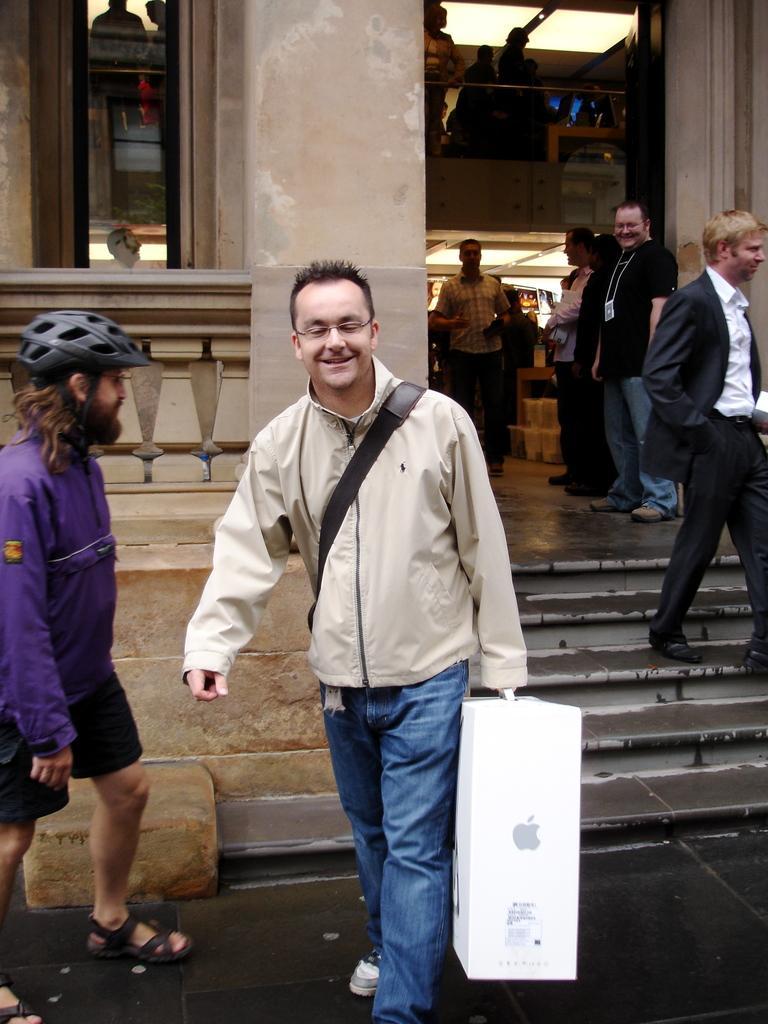Describe this image in one or two sentences. This picture describes about group of people, in the middle of the given image we can see a man, he is holding a box in his hand, beside to him we can see another man, he wore a helmet, in the background we can find few lights and a building. 